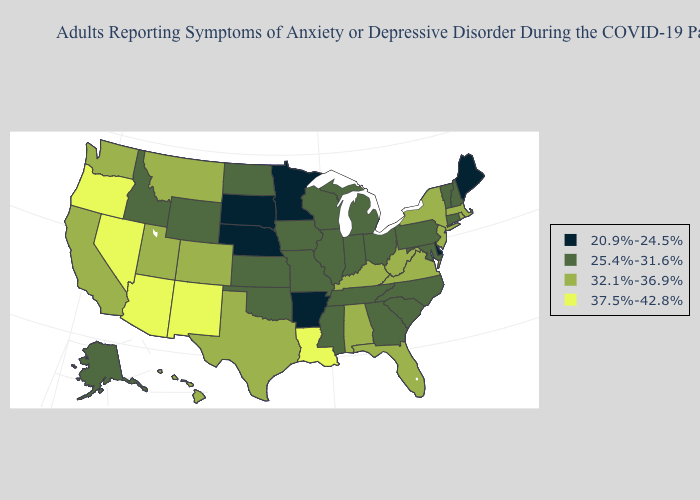Name the states that have a value in the range 25.4%-31.6%?
Concise answer only. Alaska, Connecticut, Georgia, Idaho, Illinois, Indiana, Iowa, Kansas, Maryland, Michigan, Mississippi, Missouri, New Hampshire, North Carolina, North Dakota, Ohio, Oklahoma, Pennsylvania, South Carolina, Tennessee, Vermont, Wisconsin, Wyoming. Which states hav the highest value in the West?
Write a very short answer. Arizona, Nevada, New Mexico, Oregon. Does Michigan have a higher value than New York?
Short answer required. No. Does Nebraska have the highest value in the MidWest?
Be succinct. No. What is the value of New York?
Keep it brief. 32.1%-36.9%. What is the lowest value in the Northeast?
Quick response, please. 20.9%-24.5%. How many symbols are there in the legend?
Concise answer only. 4. What is the value of Connecticut?
Be succinct. 25.4%-31.6%. How many symbols are there in the legend?
Be succinct. 4. What is the value of Washington?
Keep it brief. 32.1%-36.9%. Which states hav the highest value in the Northeast?
Be succinct. Massachusetts, New Jersey, New York, Rhode Island. Does the first symbol in the legend represent the smallest category?
Quick response, please. Yes. Name the states that have a value in the range 25.4%-31.6%?
Concise answer only. Alaska, Connecticut, Georgia, Idaho, Illinois, Indiana, Iowa, Kansas, Maryland, Michigan, Mississippi, Missouri, New Hampshire, North Carolina, North Dakota, Ohio, Oklahoma, Pennsylvania, South Carolina, Tennessee, Vermont, Wisconsin, Wyoming. Does the map have missing data?
Concise answer only. No. What is the value of Rhode Island?
Write a very short answer. 32.1%-36.9%. 